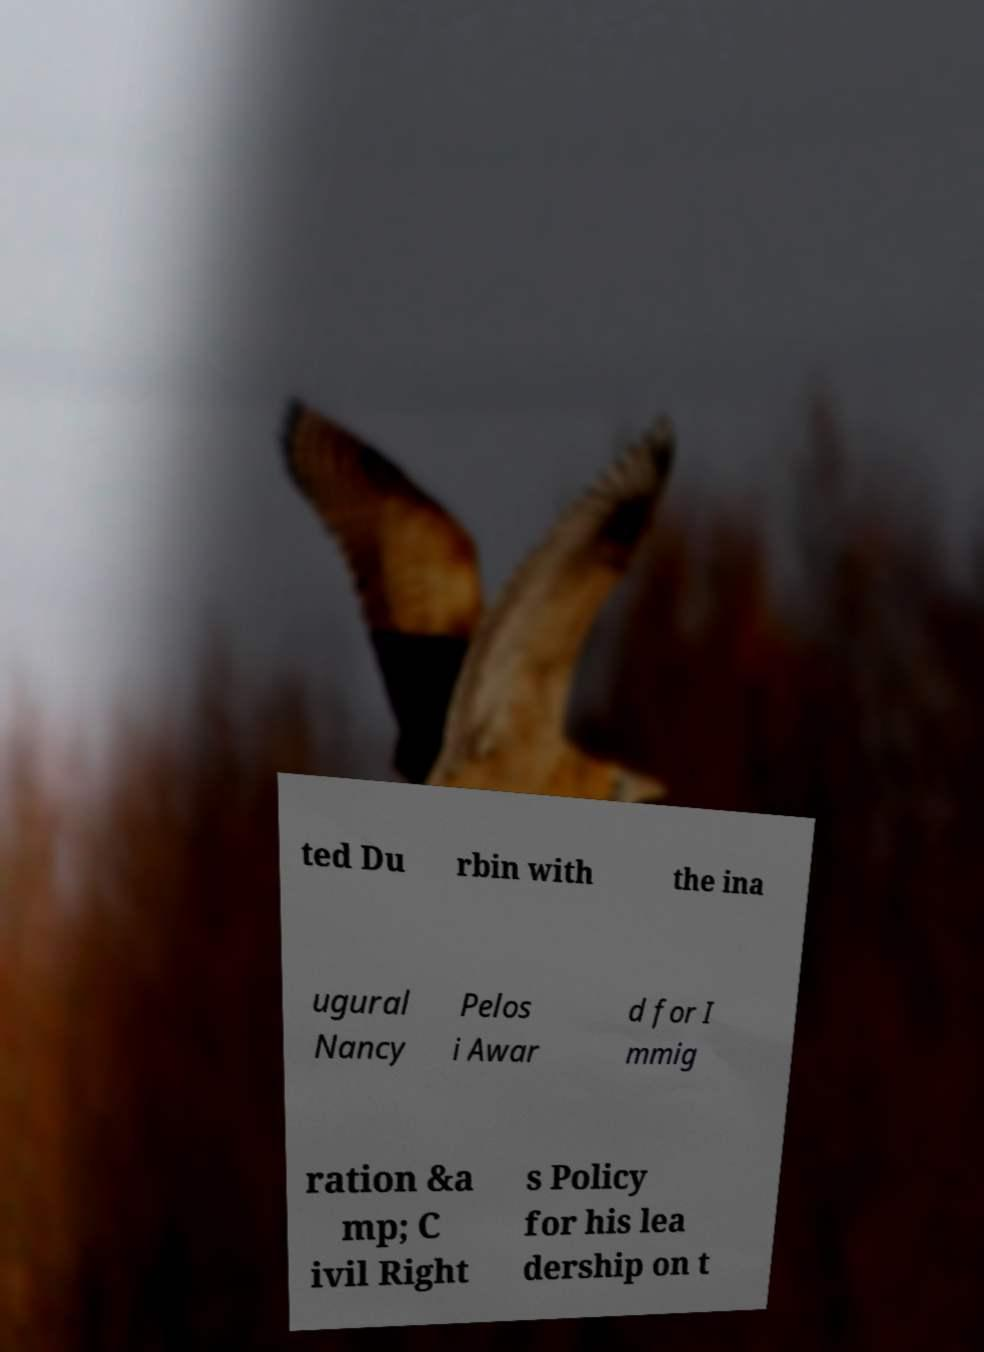Can you accurately transcribe the text from the provided image for me? ted Du rbin with the ina ugural Nancy Pelos i Awar d for I mmig ration &a mp; C ivil Right s Policy for his lea dership on t 